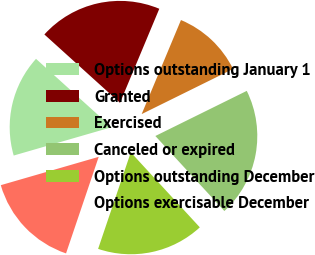Convert chart to OTSL. <chart><loc_0><loc_0><loc_500><loc_500><pie_chart><fcel>Options outstanding January 1<fcel>Granted<fcel>Exercised<fcel>Canceled or expired<fcel>Options outstanding December<fcel>Options exercisable December<nl><fcel>16.18%<fcel>19.6%<fcel>11.4%<fcel>20.46%<fcel>17.03%<fcel>15.32%<nl></chart> 